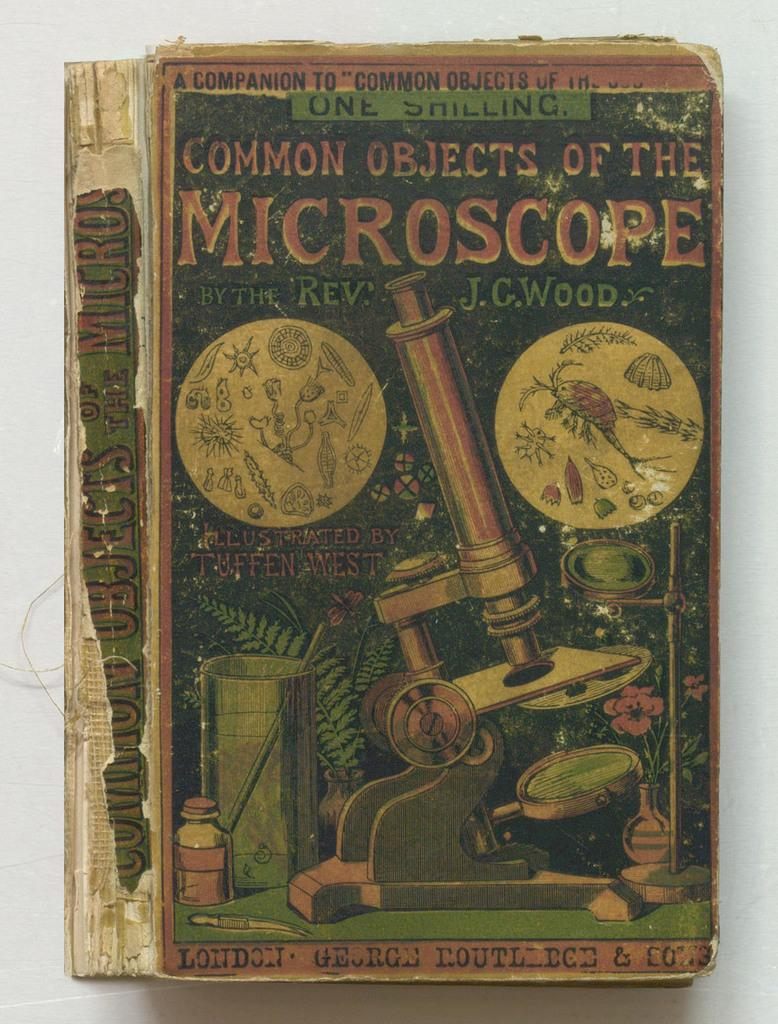Provide a one-sentence caption for the provided image. Chapter book about common objects of the microscope. 